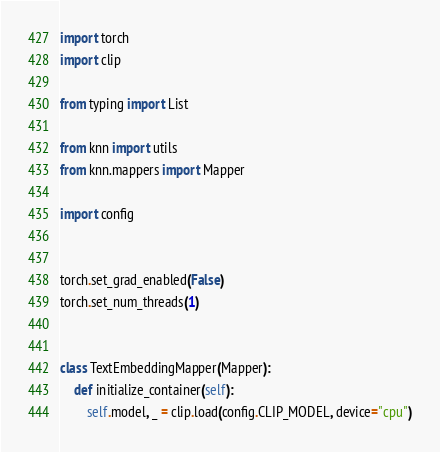<code> <loc_0><loc_0><loc_500><loc_500><_Python_>import torch
import clip

from typing import List

from knn import utils
from knn.mappers import Mapper

import config


torch.set_grad_enabled(False)
torch.set_num_threads(1)


class TextEmbeddingMapper(Mapper):
    def initialize_container(self):
        self.model, _ = clip.load(config.CLIP_MODEL, device="cpu")
</code> 